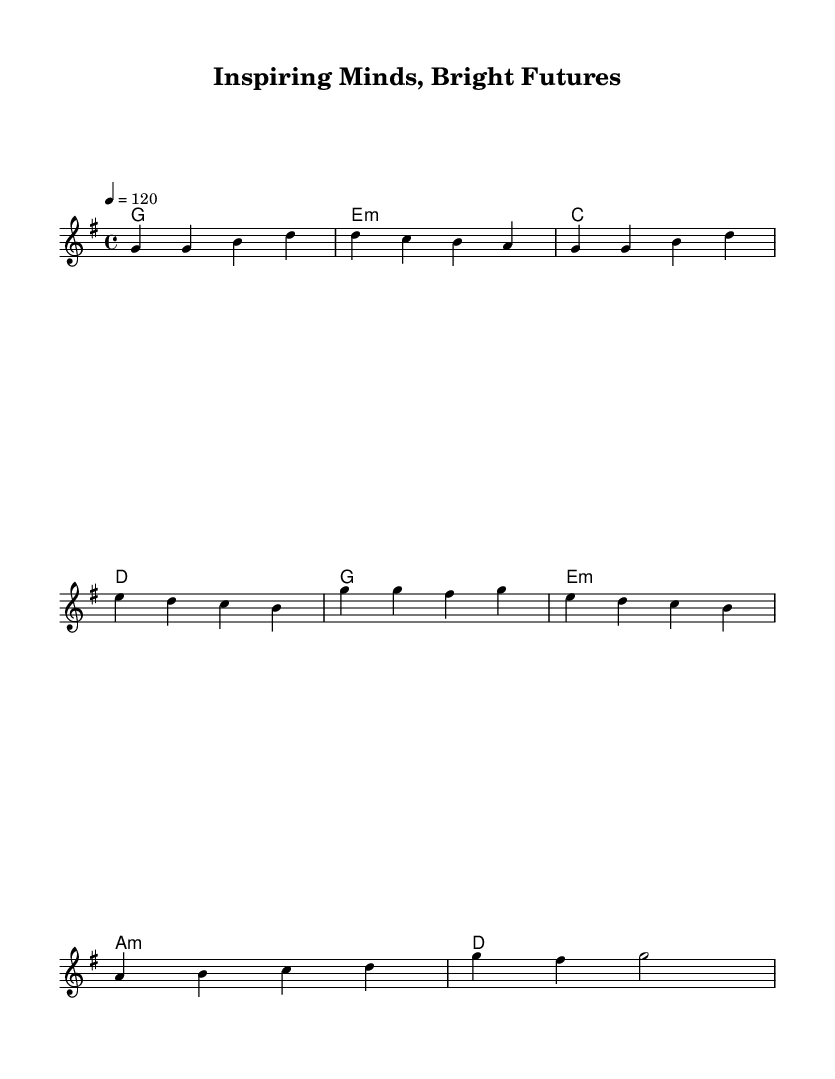What is the key signature of this music? The key signature is G major, which has one sharp (F sharp). This can be identified by looking at the beginning of the staff, where the sharp symbol indicates the key.
Answer: G major What is the time signature of this music? The time signature is four-four, indicated by the notation at the beginning of the staff which tells us there are four beats in each measure.
Answer: Four-four What is the tempo marking in this piece? The tempo marking is indicated as "4 = 120", meaning there should be 120 quarter note beats per minute. This is found at the beginning section of the score.
Answer: 120 How many measures are in the verse section? The verse section consists of four measures. By counting the sets of vertical lines (bar lines) that separate the notes, we can see there are four distinct groups.
Answer: Four What is the first note of the chorus? The first note of the chorus is G. This can be identified by looking at the staff right after the verse section where the chorus begins.
Answer: G What is the relationship between the first chord of the verse and the first note of the melody? The first chord in the verse is G major, and the first note of the melody is G, meaning the melody starts on the root of the chord. This demonstrates how melody and harmony can work together.
Answer: G major What is the mood conveyed by the melody? The melody conveys a cheerful mood, characterized by the rising and bright notes which reflect a sense of joy and positivity. The upbeat tempo and major key contribute to this cheerful feeling.
Answer: Cheerful 